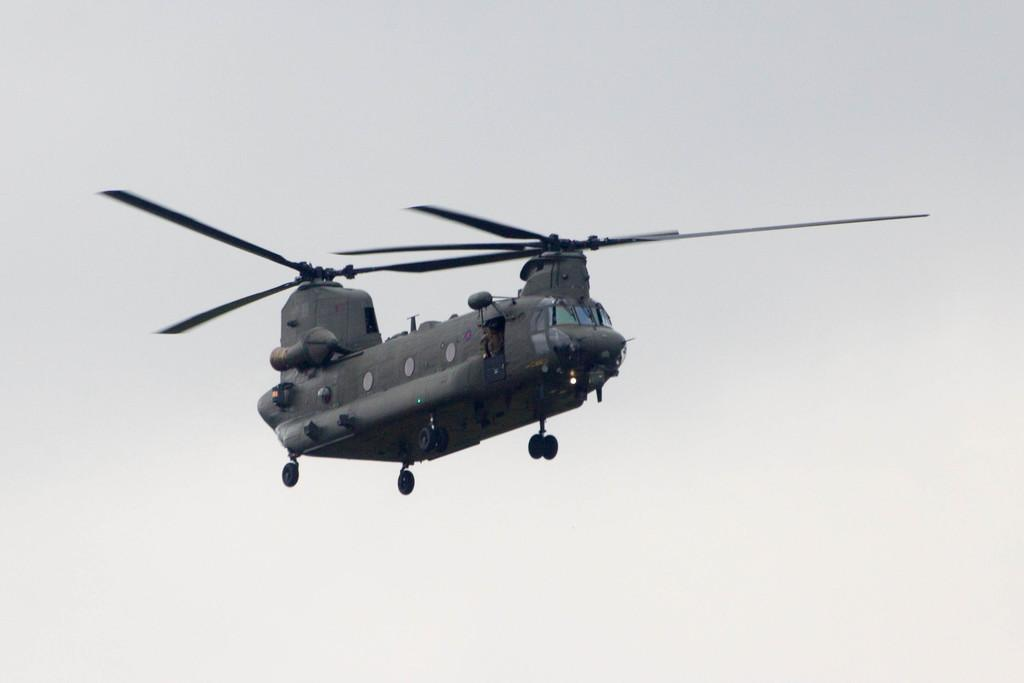What is the main subject of the picture? The main subject of the picture is a helicopter. How many propellers does the helicopter have? The helicopter has two propellers. What is the helicopter doing in the picture? The helicopter is flying in the sky. What type of property is visible in the background of the image? There is no property visible in the background of the image; it only features the helicopter flying in the sky. What is the limit of the helicopter's speed in the image? The image does not provide information about the helicopter's speed, so it cannot be determined from the picture. 